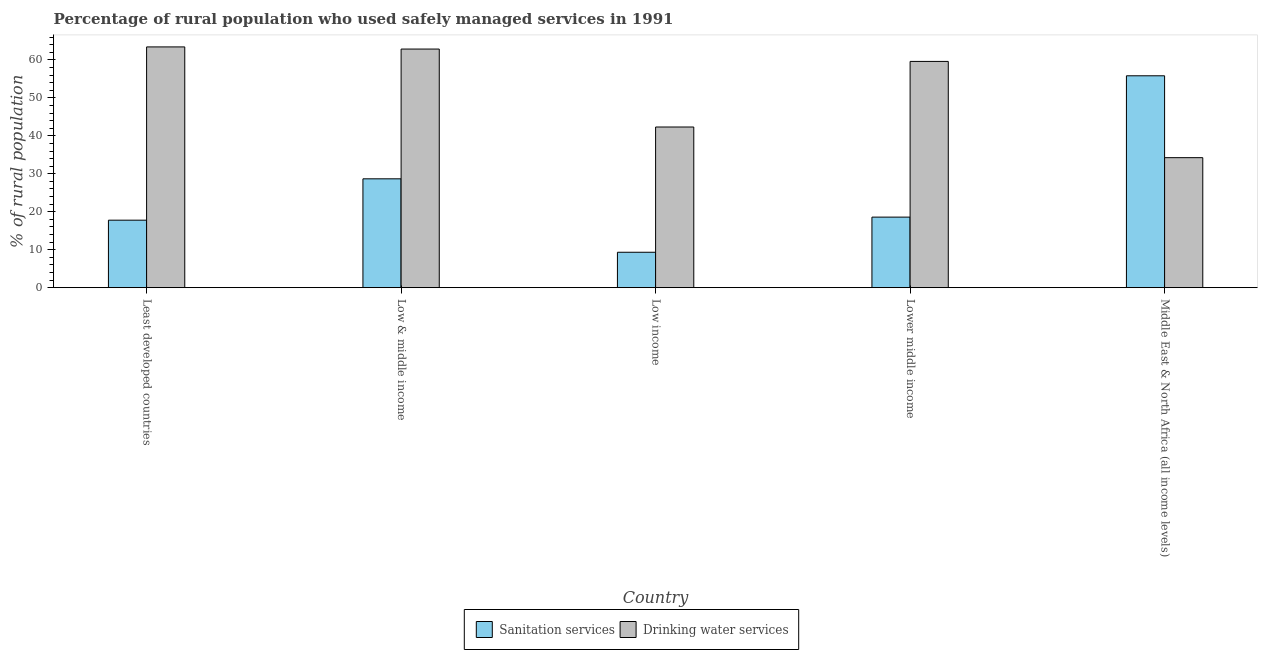How many groups of bars are there?
Provide a succinct answer. 5. Are the number of bars on each tick of the X-axis equal?
Your answer should be very brief. Yes. How many bars are there on the 1st tick from the right?
Your answer should be compact. 2. What is the label of the 2nd group of bars from the left?
Your response must be concise. Low & middle income. What is the percentage of rural population who used sanitation services in Middle East & North Africa (all income levels)?
Ensure brevity in your answer.  55.82. Across all countries, what is the maximum percentage of rural population who used sanitation services?
Provide a short and direct response. 55.82. Across all countries, what is the minimum percentage of rural population who used sanitation services?
Provide a succinct answer. 9.33. In which country was the percentage of rural population who used sanitation services maximum?
Ensure brevity in your answer.  Middle East & North Africa (all income levels). In which country was the percentage of rural population who used drinking water services minimum?
Your answer should be compact. Middle East & North Africa (all income levels). What is the total percentage of rural population who used sanitation services in the graph?
Give a very brief answer. 130.19. What is the difference between the percentage of rural population who used drinking water services in Low & middle income and that in Middle East & North Africa (all income levels)?
Ensure brevity in your answer.  28.62. What is the difference between the percentage of rural population who used sanitation services in Lower middle income and the percentage of rural population who used drinking water services in Least developed countries?
Your response must be concise. -44.85. What is the average percentage of rural population who used drinking water services per country?
Keep it short and to the point. 52.5. What is the difference between the percentage of rural population who used drinking water services and percentage of rural population who used sanitation services in Middle East & North Africa (all income levels)?
Your response must be concise. -21.57. In how many countries, is the percentage of rural population who used drinking water services greater than 58 %?
Ensure brevity in your answer.  3. What is the ratio of the percentage of rural population who used sanitation services in Least developed countries to that in Low income?
Your answer should be compact. 1.91. Is the percentage of rural population who used sanitation services in Low & middle income less than that in Middle East & North Africa (all income levels)?
Provide a succinct answer. Yes. What is the difference between the highest and the second highest percentage of rural population who used sanitation services?
Your answer should be very brief. 27.15. What is the difference between the highest and the lowest percentage of rural population who used sanitation services?
Provide a short and direct response. 46.5. What does the 2nd bar from the left in Lower middle income represents?
Your answer should be very brief. Drinking water services. What does the 2nd bar from the right in Least developed countries represents?
Provide a succinct answer. Sanitation services. How many bars are there?
Offer a very short reply. 10. How many countries are there in the graph?
Your answer should be compact. 5. What is the difference between two consecutive major ticks on the Y-axis?
Make the answer very short. 10. Does the graph contain any zero values?
Provide a succinct answer. No. How are the legend labels stacked?
Provide a succinct answer. Horizontal. What is the title of the graph?
Ensure brevity in your answer.  Percentage of rural population who used safely managed services in 1991. What is the label or title of the Y-axis?
Your answer should be compact. % of rural population. What is the % of rural population of Sanitation services in Least developed countries?
Make the answer very short. 17.78. What is the % of rural population in Drinking water services in Least developed countries?
Your answer should be compact. 63.43. What is the % of rural population of Sanitation services in Low & middle income?
Ensure brevity in your answer.  28.68. What is the % of rural population of Drinking water services in Low & middle income?
Give a very brief answer. 62.87. What is the % of rural population of Sanitation services in Low income?
Provide a succinct answer. 9.33. What is the % of rural population of Drinking water services in Low income?
Ensure brevity in your answer.  42.33. What is the % of rural population of Sanitation services in Lower middle income?
Your answer should be compact. 18.59. What is the % of rural population in Drinking water services in Lower middle income?
Make the answer very short. 59.61. What is the % of rural population of Sanitation services in Middle East & North Africa (all income levels)?
Your response must be concise. 55.82. What is the % of rural population in Drinking water services in Middle East & North Africa (all income levels)?
Ensure brevity in your answer.  34.25. Across all countries, what is the maximum % of rural population in Sanitation services?
Your response must be concise. 55.82. Across all countries, what is the maximum % of rural population of Drinking water services?
Make the answer very short. 63.43. Across all countries, what is the minimum % of rural population in Sanitation services?
Provide a short and direct response. 9.33. Across all countries, what is the minimum % of rural population in Drinking water services?
Provide a short and direct response. 34.25. What is the total % of rural population of Sanitation services in the graph?
Keep it short and to the point. 130.19. What is the total % of rural population in Drinking water services in the graph?
Give a very brief answer. 262.49. What is the difference between the % of rural population of Sanitation services in Least developed countries and that in Low & middle income?
Give a very brief answer. -10.9. What is the difference between the % of rural population of Drinking water services in Least developed countries and that in Low & middle income?
Ensure brevity in your answer.  0.56. What is the difference between the % of rural population in Sanitation services in Least developed countries and that in Low income?
Offer a terse response. 8.45. What is the difference between the % of rural population in Drinking water services in Least developed countries and that in Low income?
Your answer should be very brief. 21.11. What is the difference between the % of rural population of Sanitation services in Least developed countries and that in Lower middle income?
Your answer should be very brief. -0.81. What is the difference between the % of rural population in Drinking water services in Least developed countries and that in Lower middle income?
Your answer should be compact. 3.82. What is the difference between the % of rural population of Sanitation services in Least developed countries and that in Middle East & North Africa (all income levels)?
Ensure brevity in your answer.  -38.04. What is the difference between the % of rural population of Drinking water services in Least developed countries and that in Middle East & North Africa (all income levels)?
Your answer should be very brief. 29.18. What is the difference between the % of rural population in Sanitation services in Low & middle income and that in Low income?
Make the answer very short. 19.35. What is the difference between the % of rural population of Drinking water services in Low & middle income and that in Low income?
Provide a short and direct response. 20.54. What is the difference between the % of rural population of Sanitation services in Low & middle income and that in Lower middle income?
Keep it short and to the point. 10.09. What is the difference between the % of rural population in Drinking water services in Low & middle income and that in Lower middle income?
Your answer should be very brief. 3.26. What is the difference between the % of rural population in Sanitation services in Low & middle income and that in Middle East & North Africa (all income levels)?
Your answer should be compact. -27.15. What is the difference between the % of rural population in Drinking water services in Low & middle income and that in Middle East & North Africa (all income levels)?
Offer a very short reply. 28.62. What is the difference between the % of rural population of Sanitation services in Low income and that in Lower middle income?
Provide a short and direct response. -9.26. What is the difference between the % of rural population of Drinking water services in Low income and that in Lower middle income?
Make the answer very short. -17.29. What is the difference between the % of rural population of Sanitation services in Low income and that in Middle East & North Africa (all income levels)?
Keep it short and to the point. -46.5. What is the difference between the % of rural population in Drinking water services in Low income and that in Middle East & North Africa (all income levels)?
Offer a terse response. 8.07. What is the difference between the % of rural population in Sanitation services in Lower middle income and that in Middle East & North Africa (all income levels)?
Keep it short and to the point. -37.24. What is the difference between the % of rural population of Drinking water services in Lower middle income and that in Middle East & North Africa (all income levels)?
Keep it short and to the point. 25.36. What is the difference between the % of rural population in Sanitation services in Least developed countries and the % of rural population in Drinking water services in Low & middle income?
Give a very brief answer. -45.09. What is the difference between the % of rural population in Sanitation services in Least developed countries and the % of rural population in Drinking water services in Low income?
Offer a terse response. -24.55. What is the difference between the % of rural population of Sanitation services in Least developed countries and the % of rural population of Drinking water services in Lower middle income?
Provide a succinct answer. -41.83. What is the difference between the % of rural population of Sanitation services in Least developed countries and the % of rural population of Drinking water services in Middle East & North Africa (all income levels)?
Keep it short and to the point. -16.47. What is the difference between the % of rural population in Sanitation services in Low & middle income and the % of rural population in Drinking water services in Low income?
Keep it short and to the point. -13.65. What is the difference between the % of rural population in Sanitation services in Low & middle income and the % of rural population in Drinking water services in Lower middle income?
Offer a terse response. -30.93. What is the difference between the % of rural population of Sanitation services in Low & middle income and the % of rural population of Drinking water services in Middle East & North Africa (all income levels)?
Offer a very short reply. -5.58. What is the difference between the % of rural population of Sanitation services in Low income and the % of rural population of Drinking water services in Lower middle income?
Keep it short and to the point. -50.28. What is the difference between the % of rural population of Sanitation services in Low income and the % of rural population of Drinking water services in Middle East & North Africa (all income levels)?
Offer a terse response. -24.93. What is the difference between the % of rural population in Sanitation services in Lower middle income and the % of rural population in Drinking water services in Middle East & North Africa (all income levels)?
Offer a very short reply. -15.67. What is the average % of rural population of Sanitation services per country?
Make the answer very short. 26.04. What is the average % of rural population in Drinking water services per country?
Keep it short and to the point. 52.5. What is the difference between the % of rural population in Sanitation services and % of rural population in Drinking water services in Least developed countries?
Give a very brief answer. -45.65. What is the difference between the % of rural population in Sanitation services and % of rural population in Drinking water services in Low & middle income?
Keep it short and to the point. -34.19. What is the difference between the % of rural population in Sanitation services and % of rural population in Drinking water services in Low income?
Provide a succinct answer. -33. What is the difference between the % of rural population in Sanitation services and % of rural population in Drinking water services in Lower middle income?
Your answer should be very brief. -41.03. What is the difference between the % of rural population of Sanitation services and % of rural population of Drinking water services in Middle East & North Africa (all income levels)?
Your answer should be very brief. 21.57. What is the ratio of the % of rural population in Sanitation services in Least developed countries to that in Low & middle income?
Keep it short and to the point. 0.62. What is the ratio of the % of rural population of Sanitation services in Least developed countries to that in Low income?
Your answer should be compact. 1.91. What is the ratio of the % of rural population of Drinking water services in Least developed countries to that in Low income?
Give a very brief answer. 1.5. What is the ratio of the % of rural population in Sanitation services in Least developed countries to that in Lower middle income?
Your answer should be compact. 0.96. What is the ratio of the % of rural population of Drinking water services in Least developed countries to that in Lower middle income?
Your answer should be compact. 1.06. What is the ratio of the % of rural population of Sanitation services in Least developed countries to that in Middle East & North Africa (all income levels)?
Ensure brevity in your answer.  0.32. What is the ratio of the % of rural population of Drinking water services in Least developed countries to that in Middle East & North Africa (all income levels)?
Provide a succinct answer. 1.85. What is the ratio of the % of rural population in Sanitation services in Low & middle income to that in Low income?
Ensure brevity in your answer.  3.07. What is the ratio of the % of rural population in Drinking water services in Low & middle income to that in Low income?
Provide a succinct answer. 1.49. What is the ratio of the % of rural population in Sanitation services in Low & middle income to that in Lower middle income?
Your response must be concise. 1.54. What is the ratio of the % of rural population of Drinking water services in Low & middle income to that in Lower middle income?
Provide a short and direct response. 1.05. What is the ratio of the % of rural population in Sanitation services in Low & middle income to that in Middle East & North Africa (all income levels)?
Your answer should be compact. 0.51. What is the ratio of the % of rural population of Drinking water services in Low & middle income to that in Middle East & North Africa (all income levels)?
Keep it short and to the point. 1.84. What is the ratio of the % of rural population of Sanitation services in Low income to that in Lower middle income?
Ensure brevity in your answer.  0.5. What is the ratio of the % of rural population in Drinking water services in Low income to that in Lower middle income?
Your response must be concise. 0.71. What is the ratio of the % of rural population of Sanitation services in Low income to that in Middle East & North Africa (all income levels)?
Keep it short and to the point. 0.17. What is the ratio of the % of rural population in Drinking water services in Low income to that in Middle East & North Africa (all income levels)?
Ensure brevity in your answer.  1.24. What is the ratio of the % of rural population of Sanitation services in Lower middle income to that in Middle East & North Africa (all income levels)?
Ensure brevity in your answer.  0.33. What is the ratio of the % of rural population of Drinking water services in Lower middle income to that in Middle East & North Africa (all income levels)?
Your response must be concise. 1.74. What is the difference between the highest and the second highest % of rural population in Sanitation services?
Ensure brevity in your answer.  27.15. What is the difference between the highest and the second highest % of rural population of Drinking water services?
Ensure brevity in your answer.  0.56. What is the difference between the highest and the lowest % of rural population of Sanitation services?
Make the answer very short. 46.5. What is the difference between the highest and the lowest % of rural population of Drinking water services?
Keep it short and to the point. 29.18. 